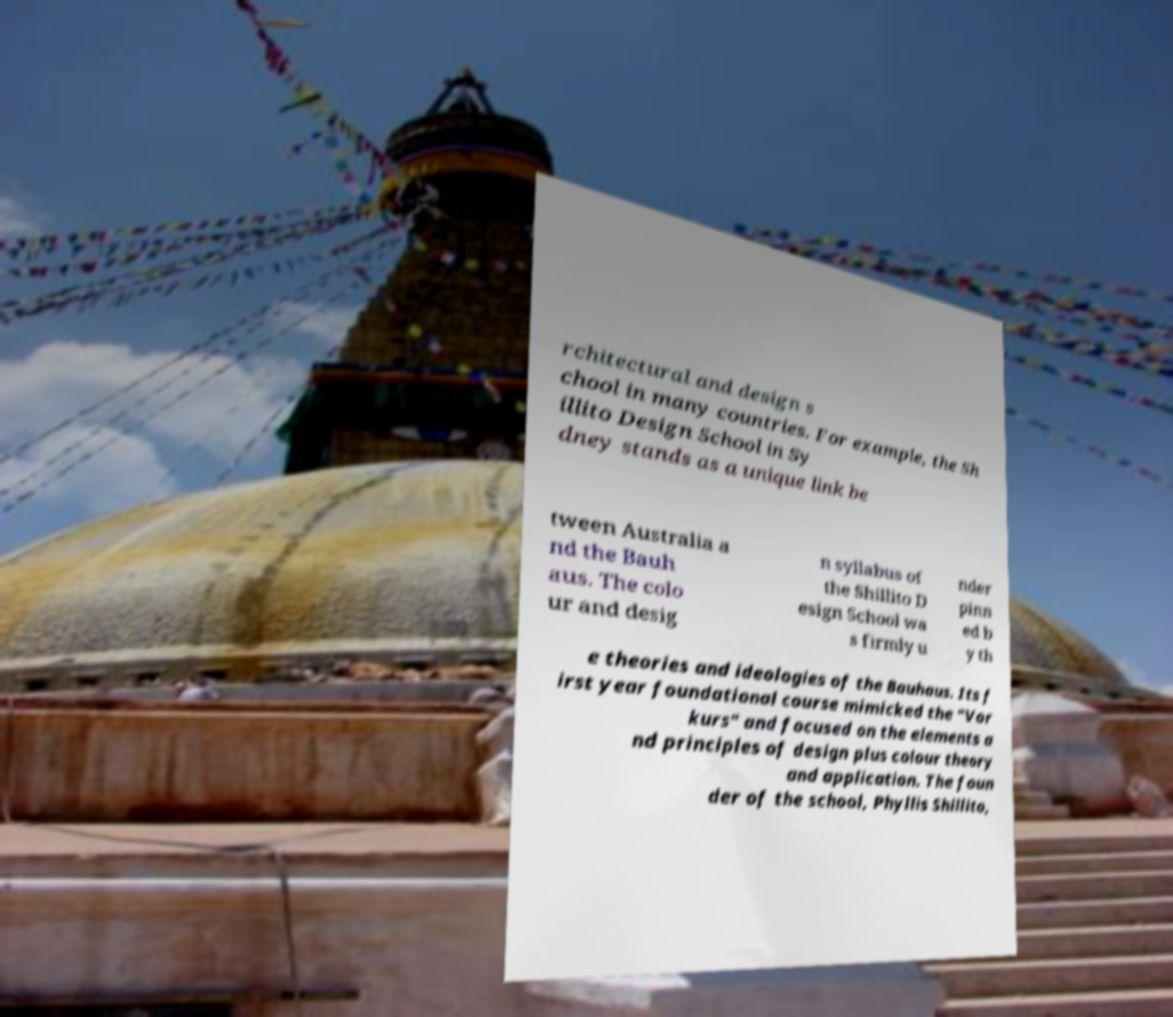What messages or text are displayed in this image? I need them in a readable, typed format. rchitectural and design s chool in many countries. For example, the Sh illito Design School in Sy dney stands as a unique link be tween Australia a nd the Bauh aus. The colo ur and desig n syllabus of the Shillito D esign School wa s firmly u nder pinn ed b y th e theories and ideologies of the Bauhaus. Its f irst year foundational course mimicked the "Vor kurs" and focused on the elements a nd principles of design plus colour theory and application. The foun der of the school, Phyllis Shillito, 